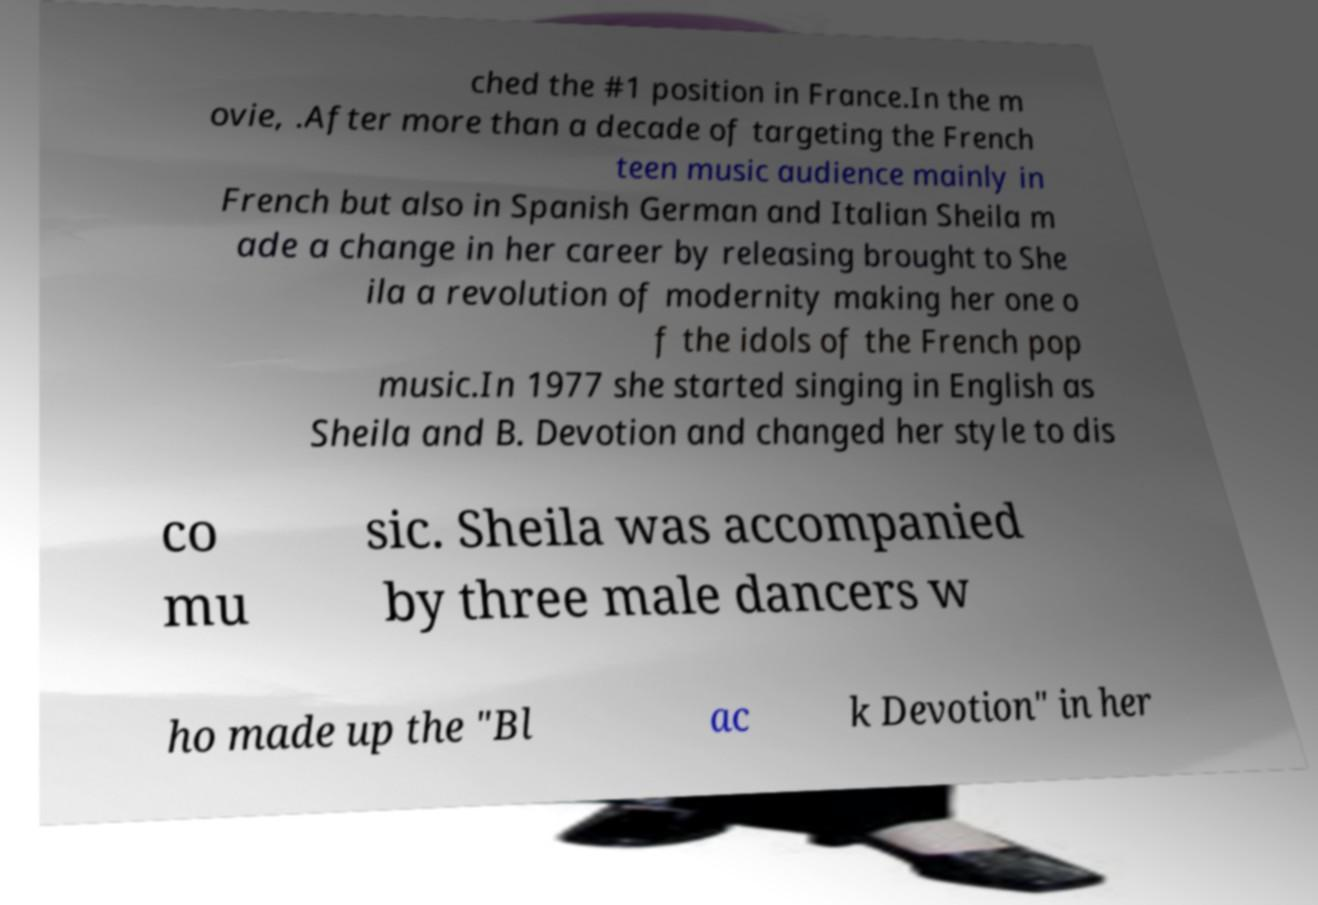There's text embedded in this image that I need extracted. Can you transcribe it verbatim? ched the #1 position in France.In the m ovie, .After more than a decade of targeting the French teen music audience mainly in French but also in Spanish German and Italian Sheila m ade a change in her career by releasing brought to She ila a revolution of modernity making her one o f the idols of the French pop music.In 1977 she started singing in English as Sheila and B. Devotion and changed her style to dis co mu sic. Sheila was accompanied by three male dancers w ho made up the "Bl ac k Devotion" in her 